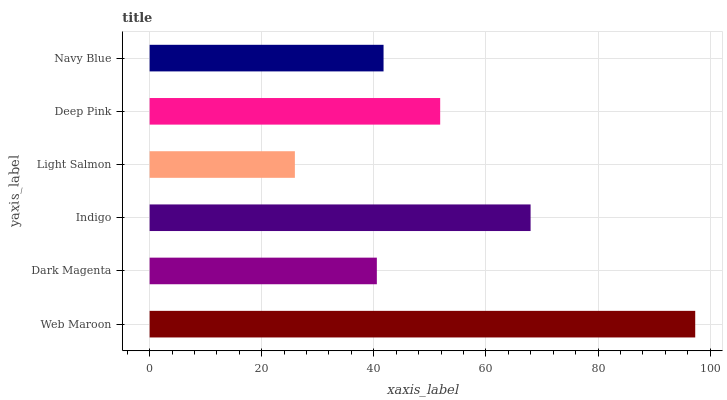Is Light Salmon the minimum?
Answer yes or no. Yes. Is Web Maroon the maximum?
Answer yes or no. Yes. Is Dark Magenta the minimum?
Answer yes or no. No. Is Dark Magenta the maximum?
Answer yes or no. No. Is Web Maroon greater than Dark Magenta?
Answer yes or no. Yes. Is Dark Magenta less than Web Maroon?
Answer yes or no. Yes. Is Dark Magenta greater than Web Maroon?
Answer yes or no. No. Is Web Maroon less than Dark Magenta?
Answer yes or no. No. Is Deep Pink the high median?
Answer yes or no. Yes. Is Navy Blue the low median?
Answer yes or no. Yes. Is Web Maroon the high median?
Answer yes or no. No. Is Deep Pink the low median?
Answer yes or no. No. 